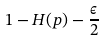Convert formula to latex. <formula><loc_0><loc_0><loc_500><loc_500>1 - H ( p ) - { \frac { \epsilon } { 2 } }</formula> 